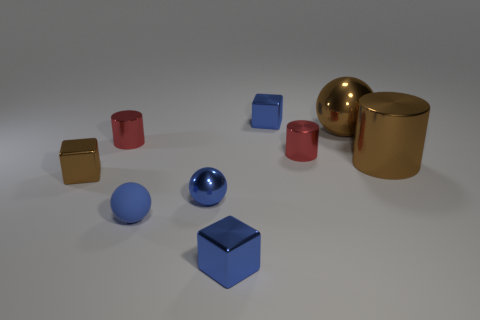What is the shape of the large brown thing that is made of the same material as the brown ball?
Ensure brevity in your answer.  Cylinder. Is there anything else that has the same shape as the small brown thing?
Give a very brief answer. Yes. What shape is the tiny brown object?
Make the answer very short. Cube. There is a blue metallic thing behind the tiny blue metallic sphere; is its shape the same as the tiny blue matte object?
Your answer should be compact. No. Are there more brown cylinders left of the big brown cylinder than blue metal cubes on the right side of the big brown sphere?
Make the answer very short. No. What number of other objects are there of the same size as the blue rubber ball?
Keep it short and to the point. 6. There is a tiny matte object; does it have the same shape as the small red shiny thing that is left of the tiny rubber sphere?
Ensure brevity in your answer.  No. How many metallic things are small yellow balls or small red cylinders?
Give a very brief answer. 2. Are there any shiny cubes that have the same color as the big shiny sphere?
Your answer should be very brief. Yes. Is there a green matte sphere?
Make the answer very short. No. 